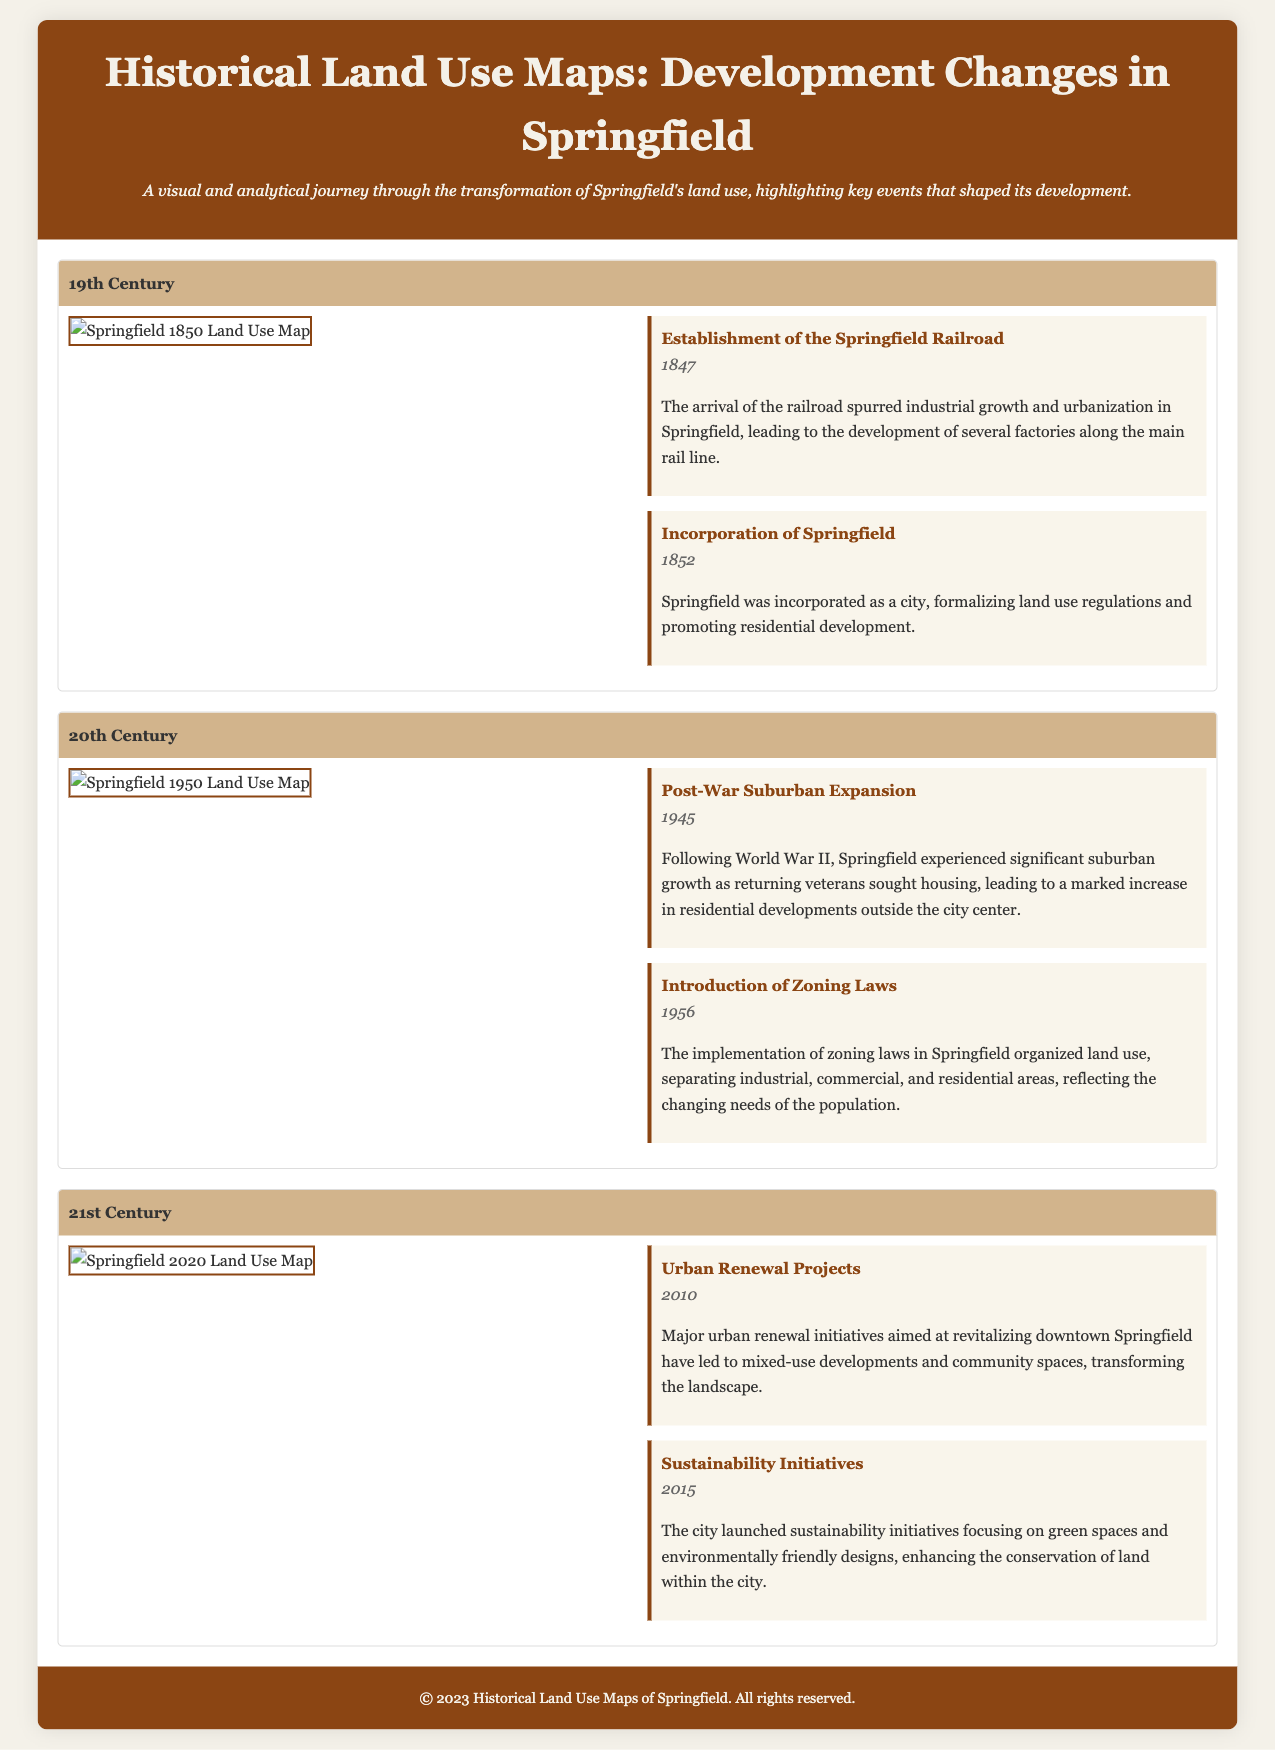What year was Springfield incorporated? The document states that Springfield was incorporated in 1852.
Answer: 1852 What event marked the establishment of the Springfield Railroad? The document notes that the establishment of the Springfield Railroad occurred in 1847.
Answer: 1847 What significant change occurred in Springfield in 1956? The document mentions the introduction of zoning laws in 1956, which organized land use.
Answer: Introduction of Zoning Laws Which map represents Springfield's land use in 2020? The document features a map specifically labeled for Springfield in the year 2020.
Answer: Springfield 2020 Land Use Map What was a major urban goal set in 2010? According to the document, urban renewal projects aimed at revitalizing downtown Springfield were initiated in 2010.
Answer: Urban Renewal Projects How did suburban growth influence Springfield after World War II? The document explains that suburban growth was significant as returning veterans sought housing, leading to increased residential developments.
Answer: Post-War Suburban Expansion What color represents the header for the 19th century period? The document uses a specific color in its design for the header, which is described as d2b48c.
Answer: d2b48c What type of development was emphasized in Springfield's 2015 initiatives? The document indicates that sustainability initiatives were focused on green spaces and environmentally friendly designs in 2015.
Answer: Sustainability Initiatives 